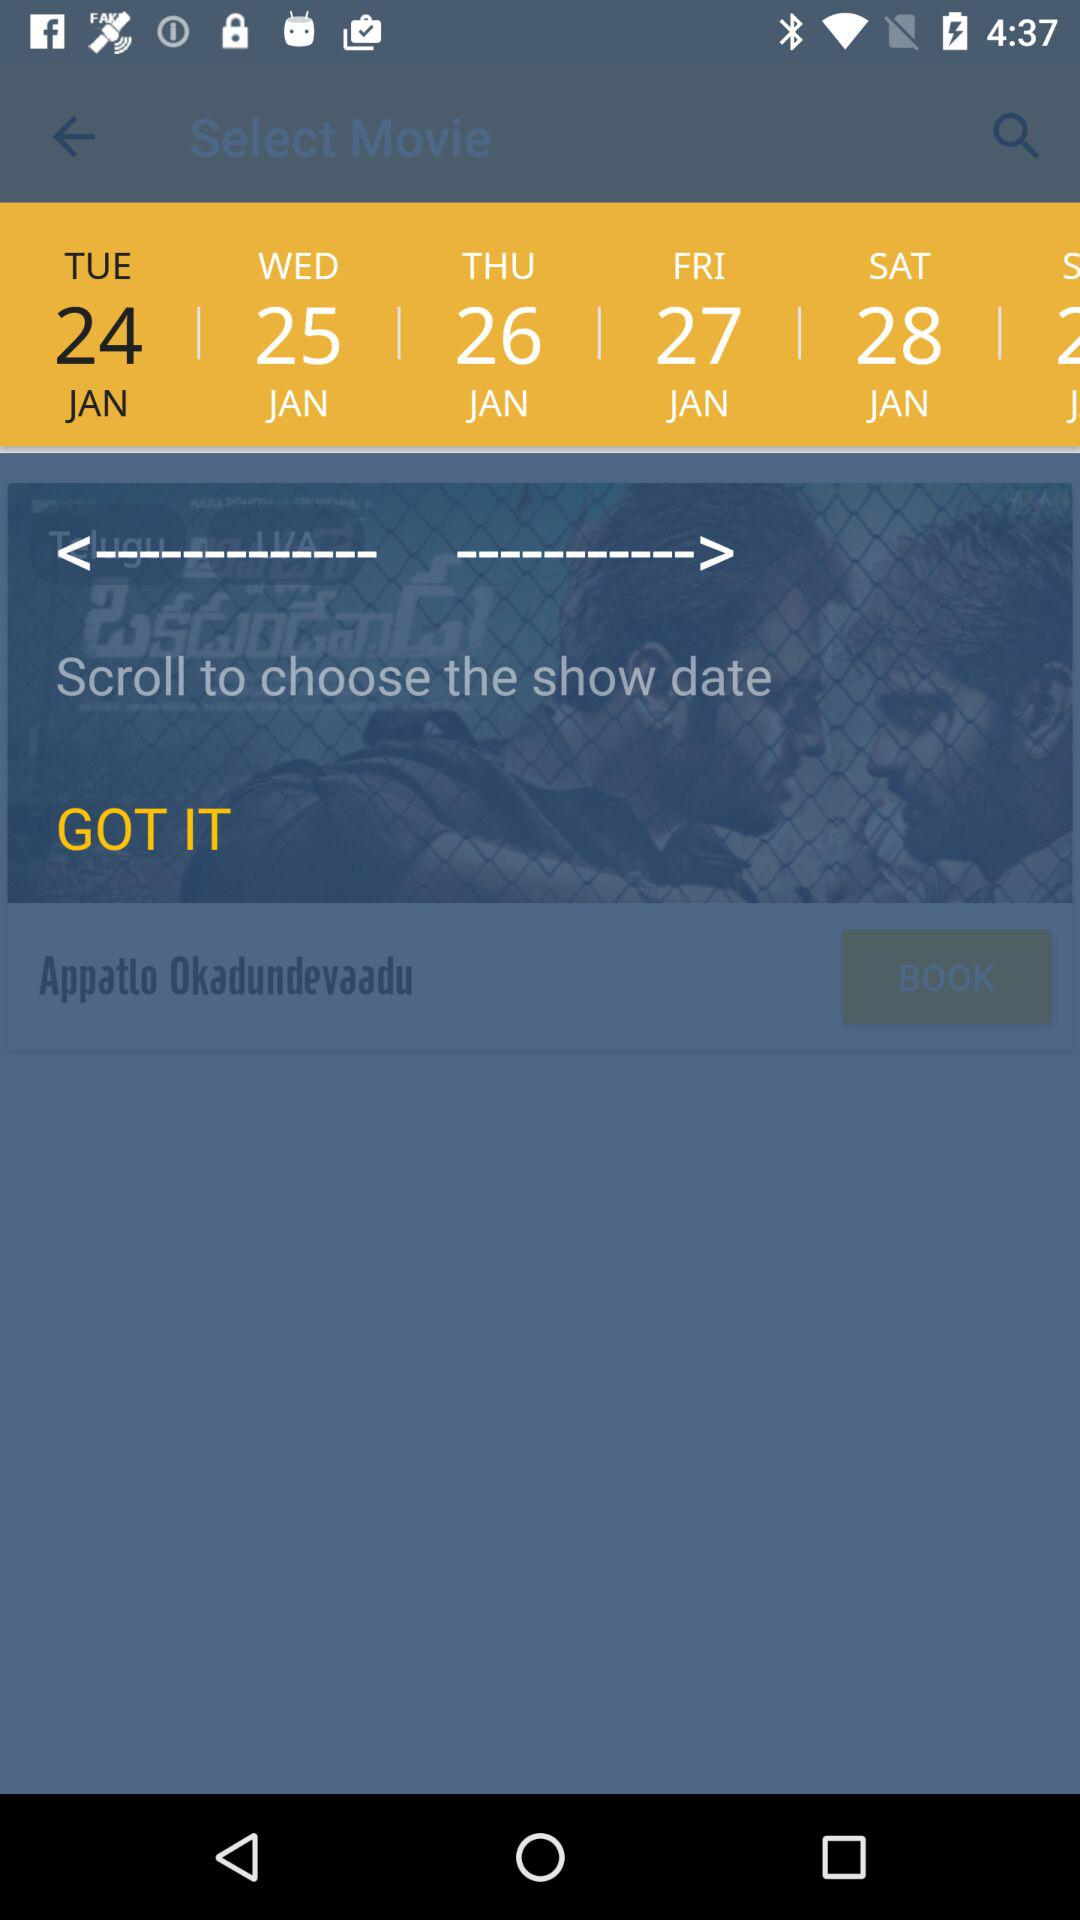How many days are available?
Answer the question using a single word or phrase. 6 